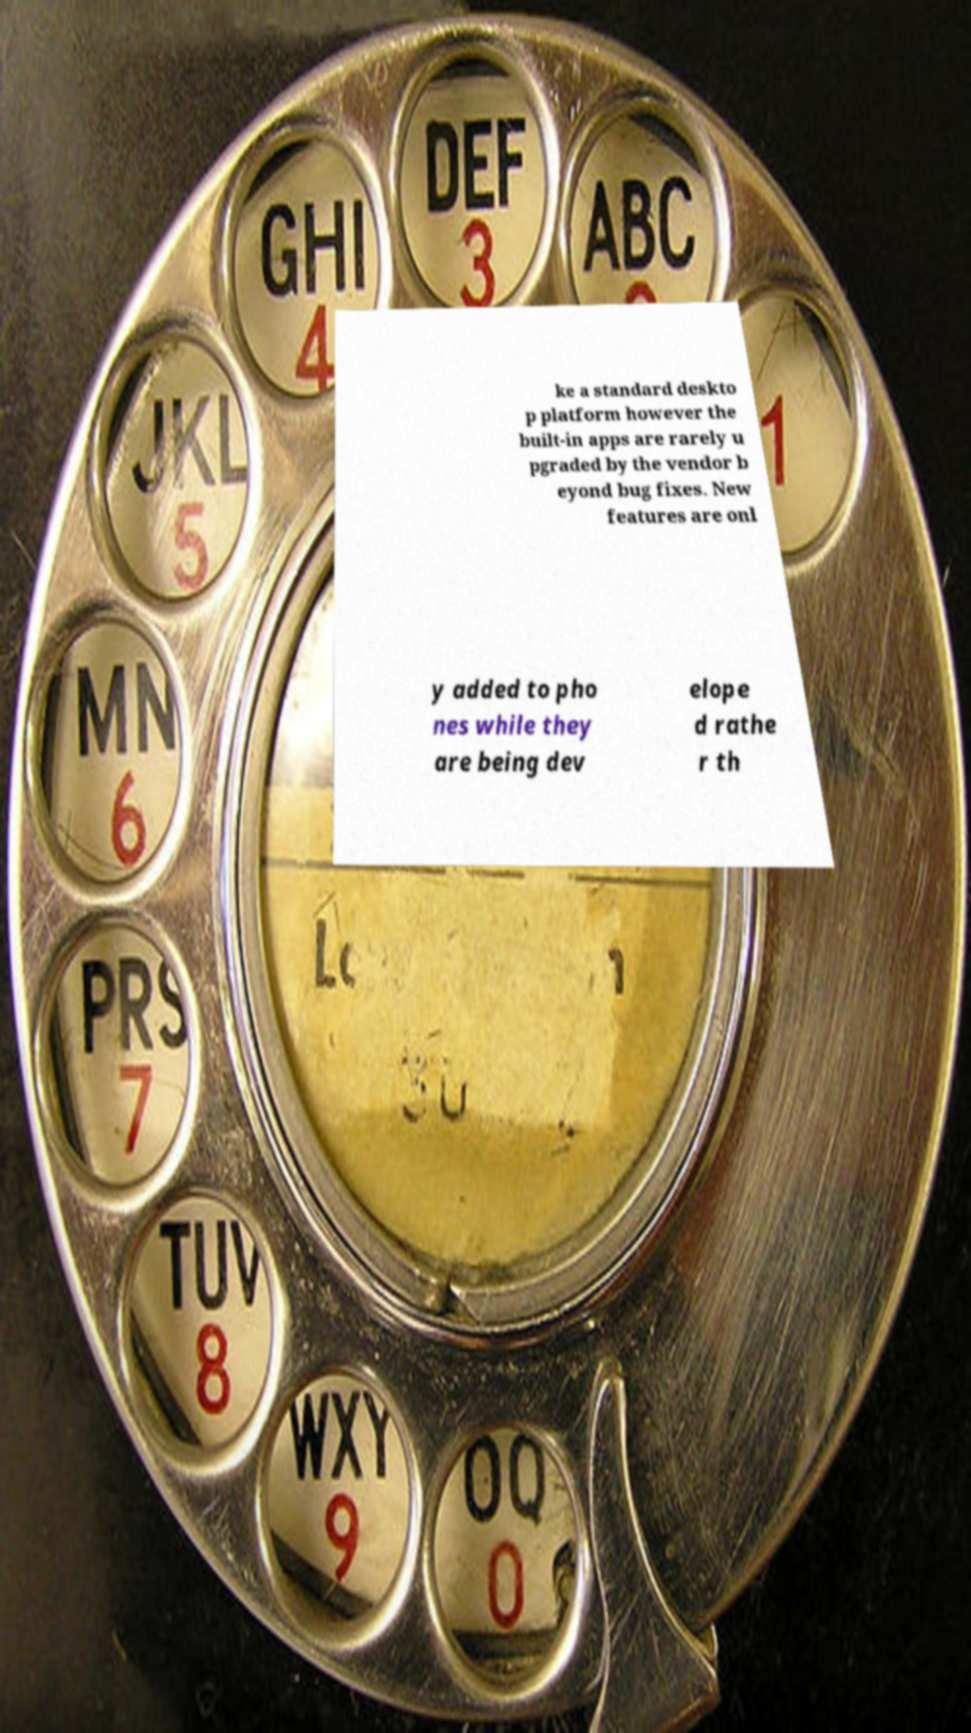Please identify and transcribe the text found in this image. ke a standard deskto p platform however the built-in apps are rarely u pgraded by the vendor b eyond bug fixes. New features are onl y added to pho nes while they are being dev elope d rathe r th 